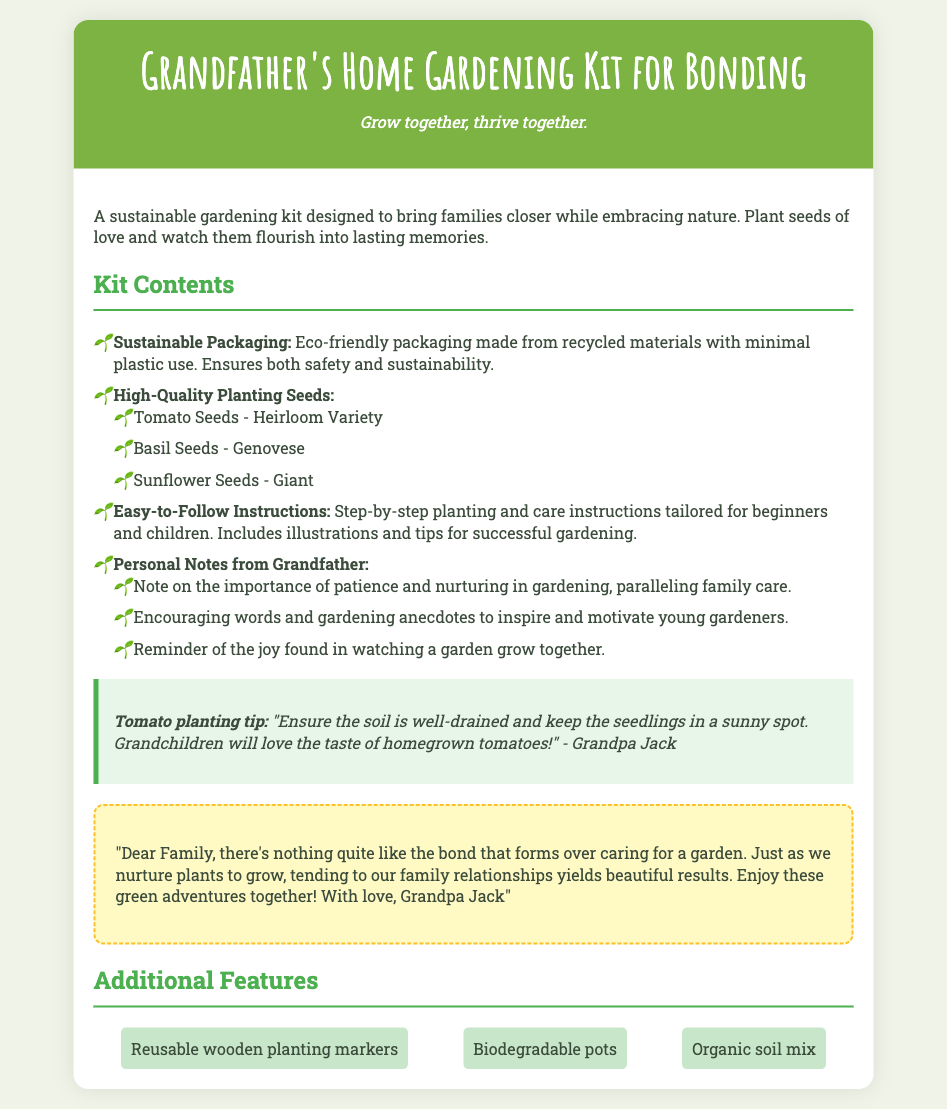What is the name of the kit? The name of the kit is prominently displayed in the header of the document.
Answer: Grandfather's Home Gardening Kit for Bonding What are the high-quality planting seeds included? The seeds included are listed in the kit contents section under high-quality planting seeds.
Answer: Tomato Seeds, Basil Seeds, Sunflower Seeds What is the importance of the personal notes from the grandfather? The document explains that these notes include encouragement and gardening anecdotes aimed at inspiring young gardeners.
Answer: Inspiration What type of packaging is used? The document mentions that the packaging is eco-friendly and made from recycled materials.
Answer: Sustainable Packaging How many additional features are listed? The features section of the document outlines three specific additional features.
Answer: Three What plant is suggested for home gardening? The note provides a specific planting tip for a particular plant, indicating its suitability for the home garden.
Answer: Tomato What is the suggested condition for the soil? The note mentions what condition the soil should be in for successful gardening.
Answer: Well-drained Who wrote the personal note? The personal note is signed by the individual who is encouraging the family to bond over gardening.
Answer: Grandpa Jack 